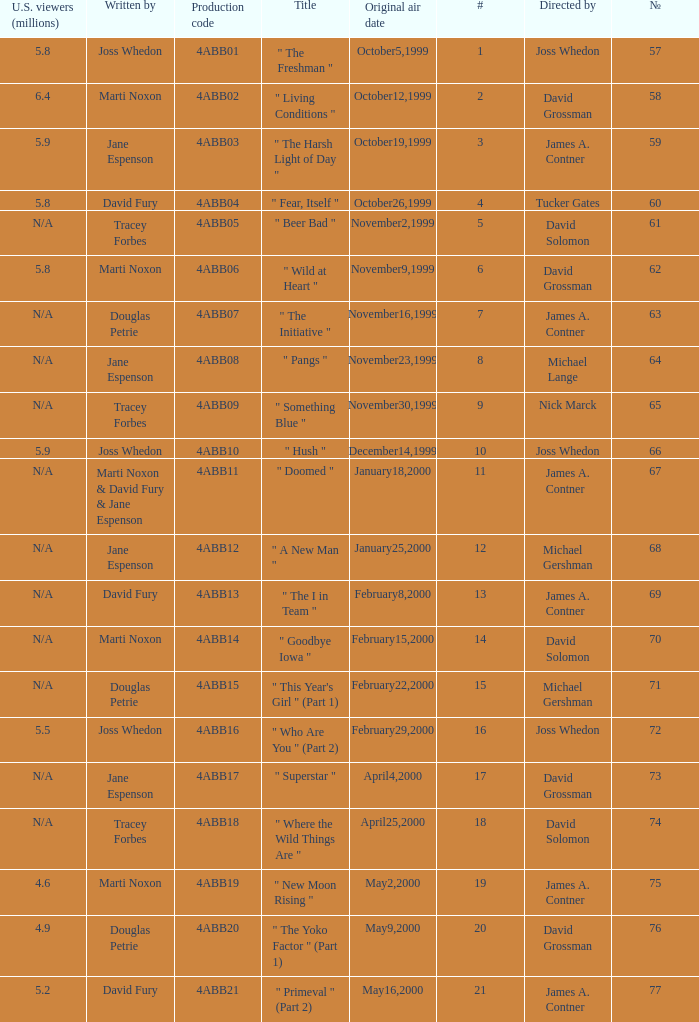What is the series No when the season 4 # is 18? 74.0. 